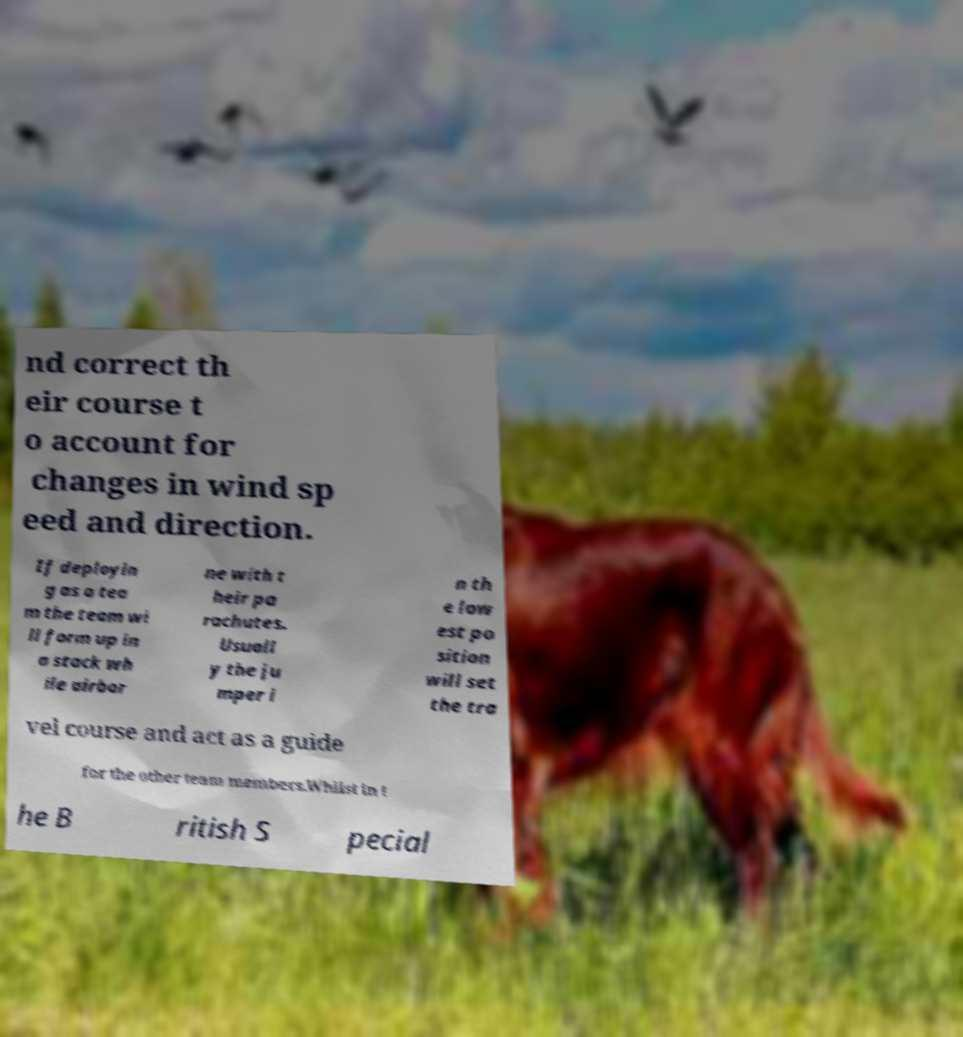Can you accurately transcribe the text from the provided image for me? nd correct th eir course t o account for changes in wind sp eed and direction. If deployin g as a tea m the team wi ll form up in a stack wh ile airbor ne with t heir pa rachutes. Usuall y the ju mper i n th e low est po sition will set the tra vel course and act as a guide for the other team members.Whilst in t he B ritish S pecial 